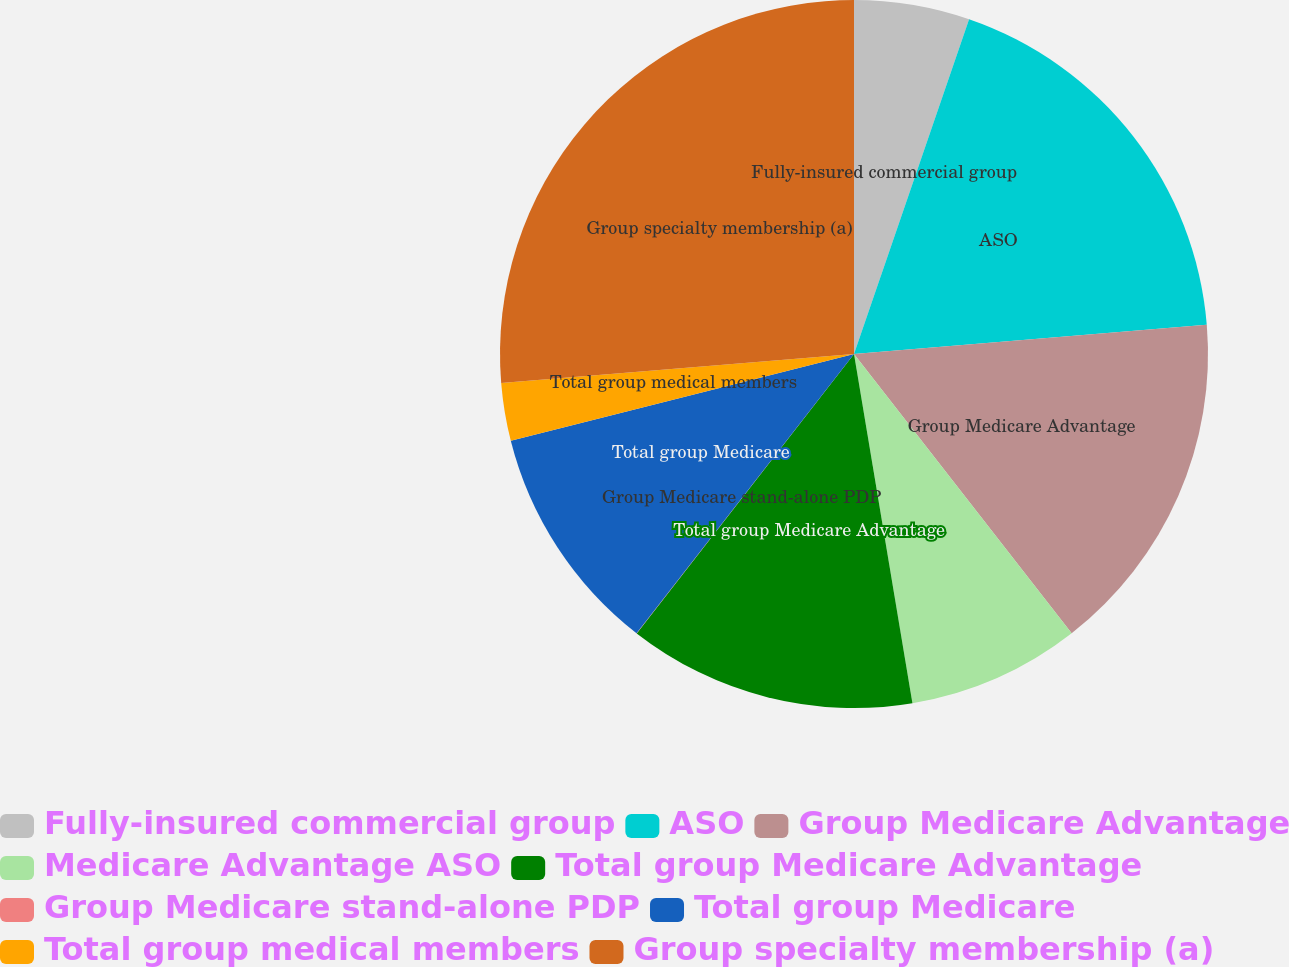Convert chart. <chart><loc_0><loc_0><loc_500><loc_500><pie_chart><fcel>Fully-insured commercial group<fcel>ASO<fcel>Group Medicare Advantage<fcel>Medicare Advantage ASO<fcel>Total group Medicare Advantage<fcel>Group Medicare stand-alone PDP<fcel>Total group Medicare<fcel>Total group medical members<fcel>Group specialty membership (a)<nl><fcel>5.27%<fcel>18.41%<fcel>15.78%<fcel>7.9%<fcel>13.16%<fcel>0.01%<fcel>10.53%<fcel>2.64%<fcel>26.3%<nl></chart> 